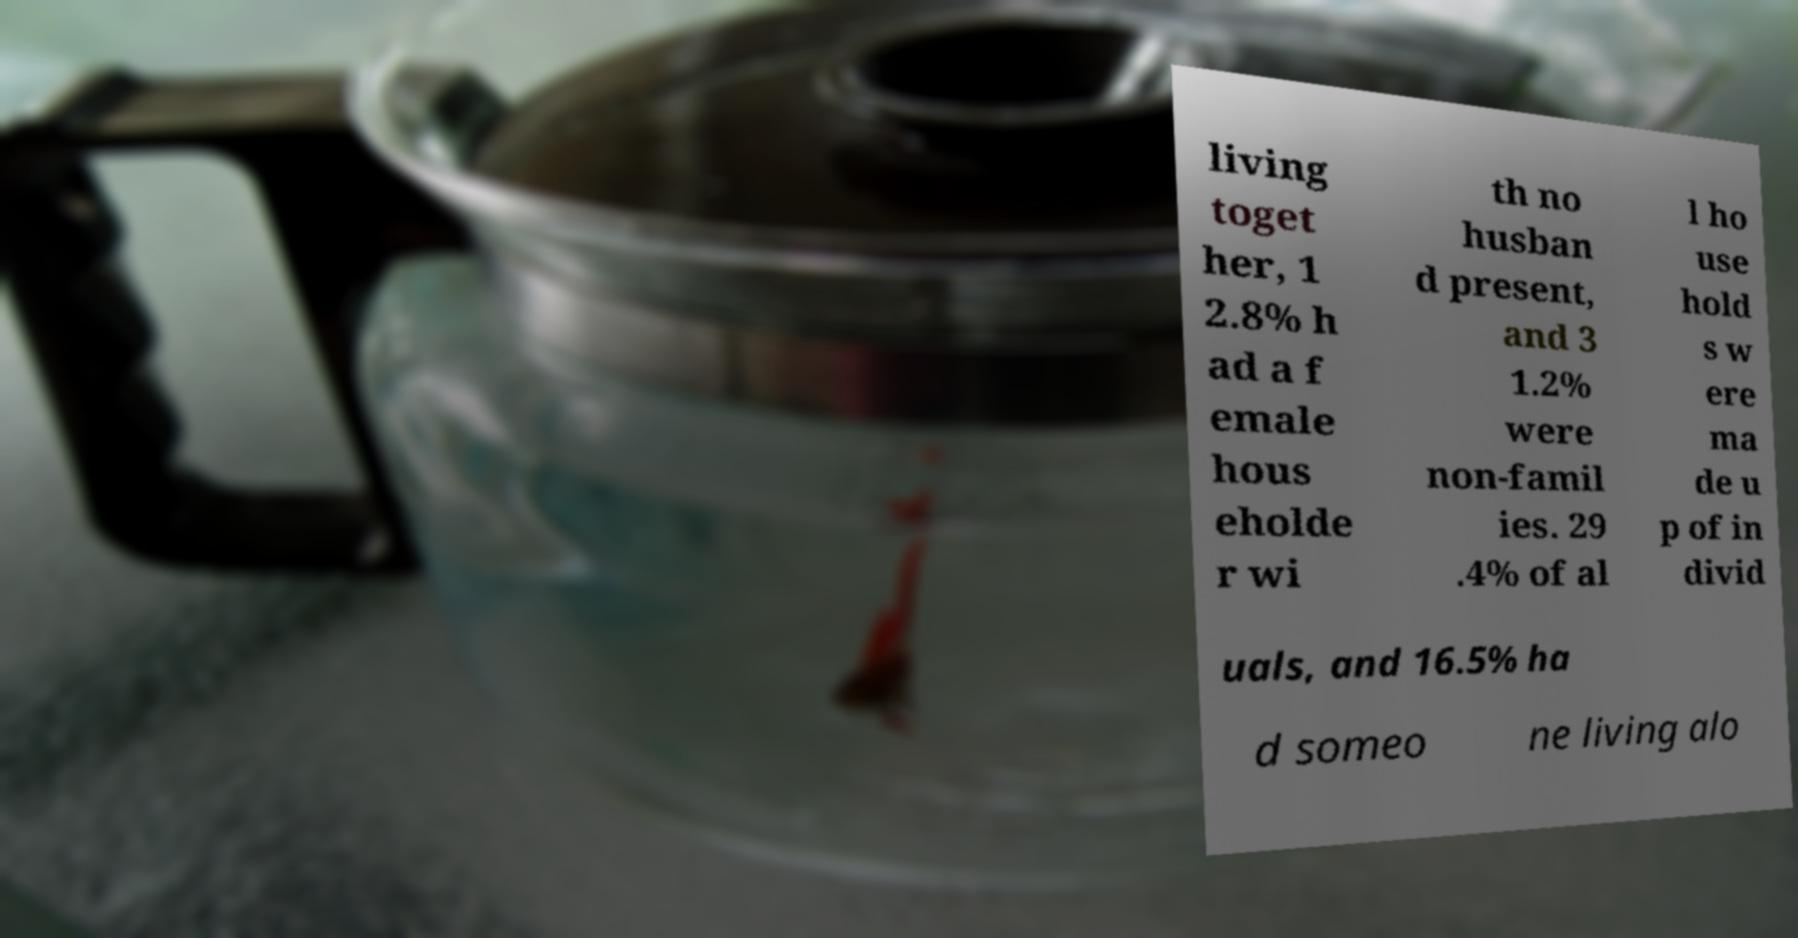Could you assist in decoding the text presented in this image and type it out clearly? living toget her, 1 2.8% h ad a f emale hous eholde r wi th no husban d present, and 3 1.2% were non-famil ies. 29 .4% of al l ho use hold s w ere ma de u p of in divid uals, and 16.5% ha d someo ne living alo 